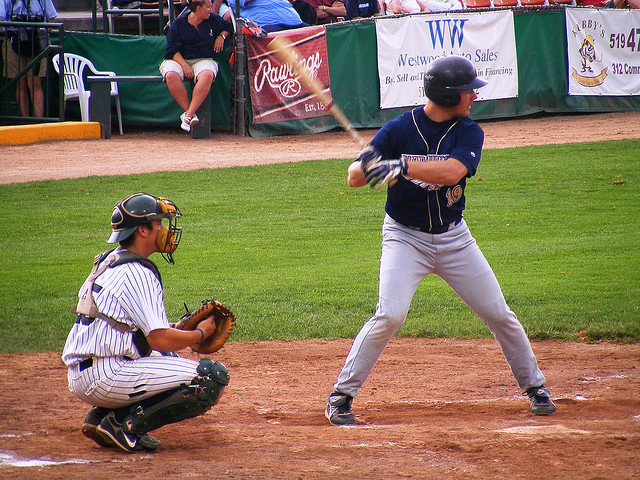<image>What is the batter's name? I don't know the batter's name. It could be Mike, Jim, Jones, George, John or Jon. What is the batter's name? I don't know the batter's name. It can be Mike, Jim, Jones, George, John, or Jon. 